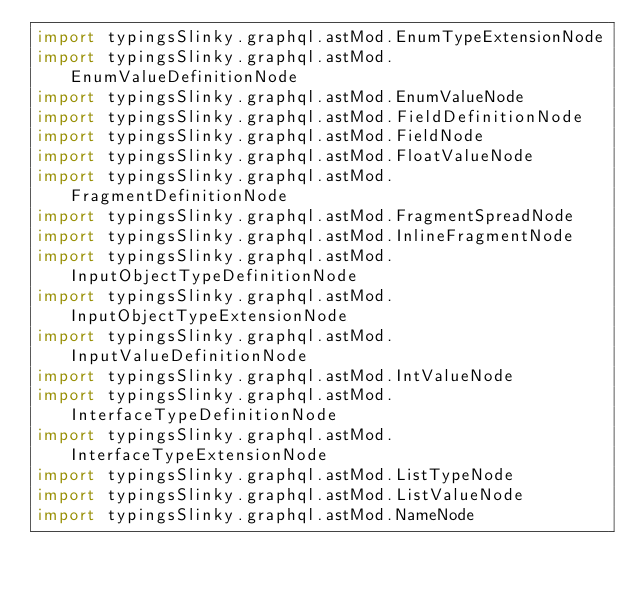<code> <loc_0><loc_0><loc_500><loc_500><_Scala_>import typingsSlinky.graphql.astMod.EnumTypeExtensionNode
import typingsSlinky.graphql.astMod.EnumValueDefinitionNode
import typingsSlinky.graphql.astMod.EnumValueNode
import typingsSlinky.graphql.astMod.FieldDefinitionNode
import typingsSlinky.graphql.astMod.FieldNode
import typingsSlinky.graphql.astMod.FloatValueNode
import typingsSlinky.graphql.astMod.FragmentDefinitionNode
import typingsSlinky.graphql.astMod.FragmentSpreadNode
import typingsSlinky.graphql.astMod.InlineFragmentNode
import typingsSlinky.graphql.astMod.InputObjectTypeDefinitionNode
import typingsSlinky.graphql.astMod.InputObjectTypeExtensionNode
import typingsSlinky.graphql.astMod.InputValueDefinitionNode
import typingsSlinky.graphql.astMod.IntValueNode
import typingsSlinky.graphql.astMod.InterfaceTypeDefinitionNode
import typingsSlinky.graphql.astMod.InterfaceTypeExtensionNode
import typingsSlinky.graphql.astMod.ListTypeNode
import typingsSlinky.graphql.astMod.ListValueNode
import typingsSlinky.graphql.astMod.NameNode</code> 